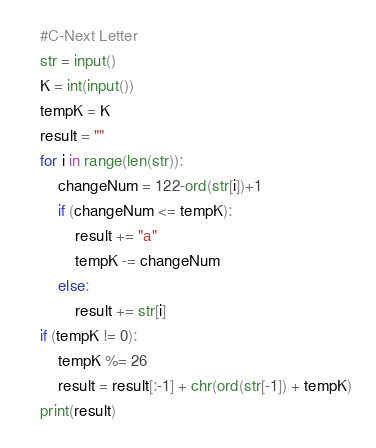Convert code to text. <code><loc_0><loc_0><loc_500><loc_500><_Python_>#C-Next Letter
str = input()
K = int(input())
tempK = K
result = ""
for i in range(len(str)):
	changeNum = 122-ord(str[i])+1
	if (changeNum <= tempK):
		result += "a"
		tempK -= changeNum
	else:
		result += str[i]
if (tempK != 0):
	tempK %= 26
	result = result[:-1] + chr(ord(str[-1]) + tempK)
print(result)
</code> 